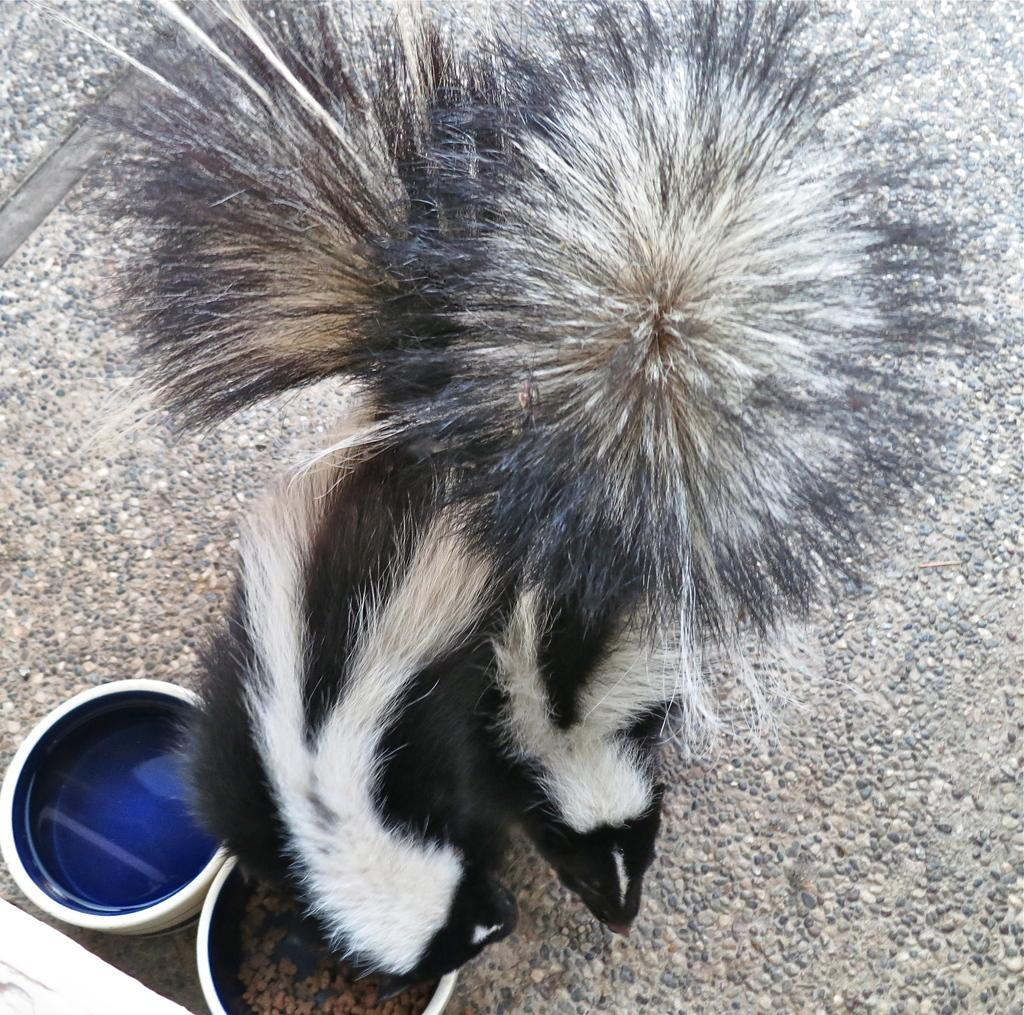What type of animals are featured in the image? There are two animals with spurs in the image. What color scheme is used for the animals? The animals are in black and white color. What objects are present at the bottom of the image? There are two bowls at the bottom of the image. How does the image convey a sense of quietness? The image does not convey a sense of quietness, as it features two animals with spurs and does not include any auditory information. 